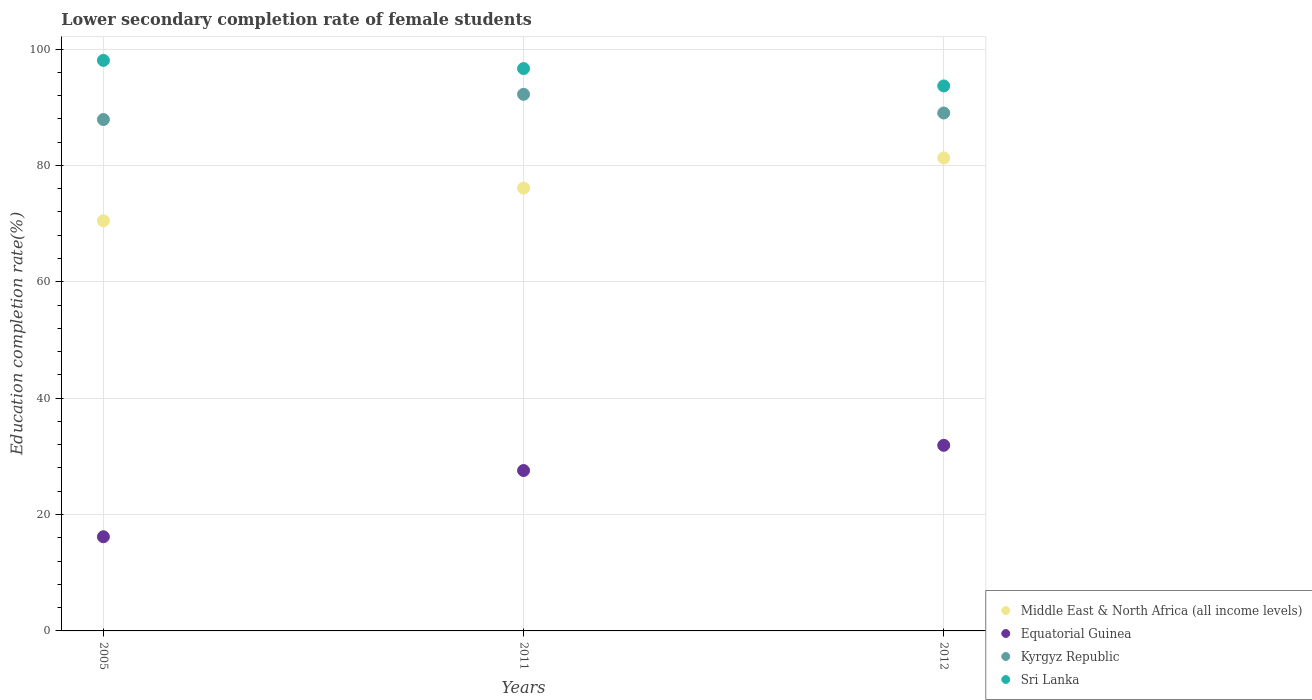Is the number of dotlines equal to the number of legend labels?
Keep it short and to the point. Yes. What is the lower secondary completion rate of female students in Sri Lanka in 2011?
Your answer should be very brief. 96.65. Across all years, what is the maximum lower secondary completion rate of female students in Kyrgyz Republic?
Your answer should be compact. 92.22. Across all years, what is the minimum lower secondary completion rate of female students in Middle East & North Africa (all income levels)?
Your answer should be very brief. 70.49. In which year was the lower secondary completion rate of female students in Kyrgyz Republic minimum?
Give a very brief answer. 2005. What is the total lower secondary completion rate of female students in Sri Lanka in the graph?
Provide a short and direct response. 288.36. What is the difference between the lower secondary completion rate of female students in Kyrgyz Republic in 2005 and that in 2012?
Provide a short and direct response. -1.12. What is the difference between the lower secondary completion rate of female students in Sri Lanka in 2011 and the lower secondary completion rate of female students in Middle East & North Africa (all income levels) in 2012?
Offer a terse response. 15.36. What is the average lower secondary completion rate of female students in Equatorial Guinea per year?
Your answer should be compact. 25.22. In the year 2005, what is the difference between the lower secondary completion rate of female students in Middle East & North Africa (all income levels) and lower secondary completion rate of female students in Sri Lanka?
Ensure brevity in your answer.  -27.57. In how many years, is the lower secondary completion rate of female students in Kyrgyz Republic greater than 84 %?
Offer a very short reply. 3. What is the ratio of the lower secondary completion rate of female students in Sri Lanka in 2011 to that in 2012?
Ensure brevity in your answer.  1.03. What is the difference between the highest and the second highest lower secondary completion rate of female students in Equatorial Guinea?
Your answer should be very brief. 4.33. What is the difference between the highest and the lowest lower secondary completion rate of female students in Kyrgyz Republic?
Ensure brevity in your answer.  4.33. Is it the case that in every year, the sum of the lower secondary completion rate of female students in Sri Lanka and lower secondary completion rate of female students in Kyrgyz Republic  is greater than the lower secondary completion rate of female students in Middle East & North Africa (all income levels)?
Offer a very short reply. Yes. Does the lower secondary completion rate of female students in Sri Lanka monotonically increase over the years?
Make the answer very short. No. Is the lower secondary completion rate of female students in Equatorial Guinea strictly greater than the lower secondary completion rate of female students in Middle East & North Africa (all income levels) over the years?
Provide a short and direct response. No. Is the lower secondary completion rate of female students in Sri Lanka strictly less than the lower secondary completion rate of female students in Equatorial Guinea over the years?
Provide a short and direct response. No. Are the values on the major ticks of Y-axis written in scientific E-notation?
Keep it short and to the point. No. Does the graph contain any zero values?
Ensure brevity in your answer.  No. Does the graph contain grids?
Keep it short and to the point. Yes. Where does the legend appear in the graph?
Provide a succinct answer. Bottom right. How many legend labels are there?
Your answer should be very brief. 4. What is the title of the graph?
Provide a short and direct response. Lower secondary completion rate of female students. What is the label or title of the Y-axis?
Provide a succinct answer. Education completion rate(%). What is the Education completion rate(%) in Middle East & North Africa (all income levels) in 2005?
Give a very brief answer. 70.49. What is the Education completion rate(%) in Equatorial Guinea in 2005?
Your response must be concise. 16.18. What is the Education completion rate(%) of Kyrgyz Republic in 2005?
Give a very brief answer. 87.89. What is the Education completion rate(%) of Sri Lanka in 2005?
Make the answer very short. 98.05. What is the Education completion rate(%) in Middle East & North Africa (all income levels) in 2011?
Offer a terse response. 76.1. What is the Education completion rate(%) of Equatorial Guinea in 2011?
Ensure brevity in your answer.  27.57. What is the Education completion rate(%) in Kyrgyz Republic in 2011?
Your response must be concise. 92.22. What is the Education completion rate(%) in Sri Lanka in 2011?
Provide a short and direct response. 96.65. What is the Education completion rate(%) in Middle East & North Africa (all income levels) in 2012?
Make the answer very short. 81.29. What is the Education completion rate(%) of Equatorial Guinea in 2012?
Make the answer very short. 31.9. What is the Education completion rate(%) in Kyrgyz Republic in 2012?
Offer a very short reply. 89.01. What is the Education completion rate(%) of Sri Lanka in 2012?
Your answer should be compact. 93.66. Across all years, what is the maximum Education completion rate(%) of Middle East & North Africa (all income levels)?
Give a very brief answer. 81.29. Across all years, what is the maximum Education completion rate(%) in Equatorial Guinea?
Your answer should be compact. 31.9. Across all years, what is the maximum Education completion rate(%) in Kyrgyz Republic?
Your response must be concise. 92.22. Across all years, what is the maximum Education completion rate(%) of Sri Lanka?
Your answer should be compact. 98.05. Across all years, what is the minimum Education completion rate(%) in Middle East & North Africa (all income levels)?
Your answer should be compact. 70.49. Across all years, what is the minimum Education completion rate(%) in Equatorial Guinea?
Make the answer very short. 16.18. Across all years, what is the minimum Education completion rate(%) of Kyrgyz Republic?
Keep it short and to the point. 87.89. Across all years, what is the minimum Education completion rate(%) in Sri Lanka?
Offer a very short reply. 93.66. What is the total Education completion rate(%) in Middle East & North Africa (all income levels) in the graph?
Provide a short and direct response. 227.87. What is the total Education completion rate(%) of Equatorial Guinea in the graph?
Your response must be concise. 75.65. What is the total Education completion rate(%) of Kyrgyz Republic in the graph?
Provide a short and direct response. 269.12. What is the total Education completion rate(%) of Sri Lanka in the graph?
Offer a terse response. 288.36. What is the difference between the Education completion rate(%) in Middle East & North Africa (all income levels) in 2005 and that in 2011?
Provide a succinct answer. -5.61. What is the difference between the Education completion rate(%) in Equatorial Guinea in 2005 and that in 2011?
Your answer should be very brief. -11.38. What is the difference between the Education completion rate(%) in Kyrgyz Republic in 2005 and that in 2011?
Provide a short and direct response. -4.33. What is the difference between the Education completion rate(%) in Sri Lanka in 2005 and that in 2011?
Offer a very short reply. 1.41. What is the difference between the Education completion rate(%) of Middle East & North Africa (all income levels) in 2005 and that in 2012?
Offer a very short reply. -10.8. What is the difference between the Education completion rate(%) in Equatorial Guinea in 2005 and that in 2012?
Your answer should be compact. -15.71. What is the difference between the Education completion rate(%) of Kyrgyz Republic in 2005 and that in 2012?
Provide a succinct answer. -1.12. What is the difference between the Education completion rate(%) of Sri Lanka in 2005 and that in 2012?
Your response must be concise. 4.39. What is the difference between the Education completion rate(%) in Middle East & North Africa (all income levels) in 2011 and that in 2012?
Provide a short and direct response. -5.19. What is the difference between the Education completion rate(%) in Equatorial Guinea in 2011 and that in 2012?
Provide a short and direct response. -4.33. What is the difference between the Education completion rate(%) in Kyrgyz Republic in 2011 and that in 2012?
Make the answer very short. 3.21. What is the difference between the Education completion rate(%) in Sri Lanka in 2011 and that in 2012?
Your answer should be very brief. 2.98. What is the difference between the Education completion rate(%) in Middle East & North Africa (all income levels) in 2005 and the Education completion rate(%) in Equatorial Guinea in 2011?
Give a very brief answer. 42.92. What is the difference between the Education completion rate(%) in Middle East & North Africa (all income levels) in 2005 and the Education completion rate(%) in Kyrgyz Republic in 2011?
Give a very brief answer. -21.74. What is the difference between the Education completion rate(%) in Middle East & North Africa (all income levels) in 2005 and the Education completion rate(%) in Sri Lanka in 2011?
Provide a succinct answer. -26.16. What is the difference between the Education completion rate(%) of Equatorial Guinea in 2005 and the Education completion rate(%) of Kyrgyz Republic in 2011?
Ensure brevity in your answer.  -76.04. What is the difference between the Education completion rate(%) in Equatorial Guinea in 2005 and the Education completion rate(%) in Sri Lanka in 2011?
Your answer should be compact. -80.46. What is the difference between the Education completion rate(%) in Kyrgyz Republic in 2005 and the Education completion rate(%) in Sri Lanka in 2011?
Ensure brevity in your answer.  -8.76. What is the difference between the Education completion rate(%) in Middle East & North Africa (all income levels) in 2005 and the Education completion rate(%) in Equatorial Guinea in 2012?
Offer a very short reply. 38.59. What is the difference between the Education completion rate(%) of Middle East & North Africa (all income levels) in 2005 and the Education completion rate(%) of Kyrgyz Republic in 2012?
Keep it short and to the point. -18.52. What is the difference between the Education completion rate(%) of Middle East & North Africa (all income levels) in 2005 and the Education completion rate(%) of Sri Lanka in 2012?
Offer a very short reply. -23.18. What is the difference between the Education completion rate(%) of Equatorial Guinea in 2005 and the Education completion rate(%) of Kyrgyz Republic in 2012?
Give a very brief answer. -72.83. What is the difference between the Education completion rate(%) in Equatorial Guinea in 2005 and the Education completion rate(%) in Sri Lanka in 2012?
Your answer should be very brief. -77.48. What is the difference between the Education completion rate(%) of Kyrgyz Republic in 2005 and the Education completion rate(%) of Sri Lanka in 2012?
Provide a succinct answer. -5.77. What is the difference between the Education completion rate(%) in Middle East & North Africa (all income levels) in 2011 and the Education completion rate(%) in Equatorial Guinea in 2012?
Your answer should be compact. 44.2. What is the difference between the Education completion rate(%) in Middle East & North Africa (all income levels) in 2011 and the Education completion rate(%) in Kyrgyz Republic in 2012?
Offer a very short reply. -12.91. What is the difference between the Education completion rate(%) of Middle East & North Africa (all income levels) in 2011 and the Education completion rate(%) of Sri Lanka in 2012?
Your answer should be very brief. -17.56. What is the difference between the Education completion rate(%) of Equatorial Guinea in 2011 and the Education completion rate(%) of Kyrgyz Republic in 2012?
Keep it short and to the point. -61.44. What is the difference between the Education completion rate(%) of Equatorial Guinea in 2011 and the Education completion rate(%) of Sri Lanka in 2012?
Keep it short and to the point. -66.1. What is the difference between the Education completion rate(%) in Kyrgyz Republic in 2011 and the Education completion rate(%) in Sri Lanka in 2012?
Keep it short and to the point. -1.44. What is the average Education completion rate(%) in Middle East & North Africa (all income levels) per year?
Give a very brief answer. 75.96. What is the average Education completion rate(%) in Equatorial Guinea per year?
Your response must be concise. 25.22. What is the average Education completion rate(%) of Kyrgyz Republic per year?
Provide a short and direct response. 89.71. What is the average Education completion rate(%) in Sri Lanka per year?
Provide a succinct answer. 96.12. In the year 2005, what is the difference between the Education completion rate(%) of Middle East & North Africa (all income levels) and Education completion rate(%) of Equatorial Guinea?
Your answer should be compact. 54.3. In the year 2005, what is the difference between the Education completion rate(%) of Middle East & North Africa (all income levels) and Education completion rate(%) of Kyrgyz Republic?
Your response must be concise. -17.4. In the year 2005, what is the difference between the Education completion rate(%) in Middle East & North Africa (all income levels) and Education completion rate(%) in Sri Lanka?
Ensure brevity in your answer.  -27.57. In the year 2005, what is the difference between the Education completion rate(%) in Equatorial Guinea and Education completion rate(%) in Kyrgyz Republic?
Your response must be concise. -71.7. In the year 2005, what is the difference between the Education completion rate(%) of Equatorial Guinea and Education completion rate(%) of Sri Lanka?
Offer a very short reply. -81.87. In the year 2005, what is the difference between the Education completion rate(%) of Kyrgyz Republic and Education completion rate(%) of Sri Lanka?
Ensure brevity in your answer.  -10.16. In the year 2011, what is the difference between the Education completion rate(%) of Middle East & North Africa (all income levels) and Education completion rate(%) of Equatorial Guinea?
Your response must be concise. 48.53. In the year 2011, what is the difference between the Education completion rate(%) in Middle East & North Africa (all income levels) and Education completion rate(%) in Kyrgyz Republic?
Provide a succinct answer. -16.12. In the year 2011, what is the difference between the Education completion rate(%) of Middle East & North Africa (all income levels) and Education completion rate(%) of Sri Lanka?
Keep it short and to the point. -20.55. In the year 2011, what is the difference between the Education completion rate(%) of Equatorial Guinea and Education completion rate(%) of Kyrgyz Republic?
Your answer should be very brief. -64.66. In the year 2011, what is the difference between the Education completion rate(%) of Equatorial Guinea and Education completion rate(%) of Sri Lanka?
Keep it short and to the point. -69.08. In the year 2011, what is the difference between the Education completion rate(%) in Kyrgyz Republic and Education completion rate(%) in Sri Lanka?
Provide a short and direct response. -4.42. In the year 2012, what is the difference between the Education completion rate(%) in Middle East & North Africa (all income levels) and Education completion rate(%) in Equatorial Guinea?
Provide a short and direct response. 49.39. In the year 2012, what is the difference between the Education completion rate(%) in Middle East & North Africa (all income levels) and Education completion rate(%) in Kyrgyz Republic?
Your answer should be compact. -7.72. In the year 2012, what is the difference between the Education completion rate(%) of Middle East & North Africa (all income levels) and Education completion rate(%) of Sri Lanka?
Make the answer very short. -12.38. In the year 2012, what is the difference between the Education completion rate(%) in Equatorial Guinea and Education completion rate(%) in Kyrgyz Republic?
Offer a terse response. -57.11. In the year 2012, what is the difference between the Education completion rate(%) of Equatorial Guinea and Education completion rate(%) of Sri Lanka?
Your response must be concise. -61.76. In the year 2012, what is the difference between the Education completion rate(%) of Kyrgyz Republic and Education completion rate(%) of Sri Lanka?
Provide a succinct answer. -4.65. What is the ratio of the Education completion rate(%) in Middle East & North Africa (all income levels) in 2005 to that in 2011?
Provide a short and direct response. 0.93. What is the ratio of the Education completion rate(%) of Equatorial Guinea in 2005 to that in 2011?
Your answer should be very brief. 0.59. What is the ratio of the Education completion rate(%) in Kyrgyz Republic in 2005 to that in 2011?
Keep it short and to the point. 0.95. What is the ratio of the Education completion rate(%) of Sri Lanka in 2005 to that in 2011?
Offer a very short reply. 1.01. What is the ratio of the Education completion rate(%) of Middle East & North Africa (all income levels) in 2005 to that in 2012?
Your response must be concise. 0.87. What is the ratio of the Education completion rate(%) in Equatorial Guinea in 2005 to that in 2012?
Offer a terse response. 0.51. What is the ratio of the Education completion rate(%) in Kyrgyz Republic in 2005 to that in 2012?
Provide a succinct answer. 0.99. What is the ratio of the Education completion rate(%) of Sri Lanka in 2005 to that in 2012?
Keep it short and to the point. 1.05. What is the ratio of the Education completion rate(%) of Middle East & North Africa (all income levels) in 2011 to that in 2012?
Ensure brevity in your answer.  0.94. What is the ratio of the Education completion rate(%) of Equatorial Guinea in 2011 to that in 2012?
Ensure brevity in your answer.  0.86. What is the ratio of the Education completion rate(%) in Kyrgyz Republic in 2011 to that in 2012?
Your answer should be compact. 1.04. What is the ratio of the Education completion rate(%) in Sri Lanka in 2011 to that in 2012?
Your answer should be very brief. 1.03. What is the difference between the highest and the second highest Education completion rate(%) in Middle East & North Africa (all income levels)?
Provide a succinct answer. 5.19. What is the difference between the highest and the second highest Education completion rate(%) of Equatorial Guinea?
Make the answer very short. 4.33. What is the difference between the highest and the second highest Education completion rate(%) of Kyrgyz Republic?
Provide a succinct answer. 3.21. What is the difference between the highest and the second highest Education completion rate(%) of Sri Lanka?
Make the answer very short. 1.41. What is the difference between the highest and the lowest Education completion rate(%) of Middle East & North Africa (all income levels)?
Ensure brevity in your answer.  10.8. What is the difference between the highest and the lowest Education completion rate(%) of Equatorial Guinea?
Keep it short and to the point. 15.71. What is the difference between the highest and the lowest Education completion rate(%) in Kyrgyz Republic?
Give a very brief answer. 4.33. What is the difference between the highest and the lowest Education completion rate(%) of Sri Lanka?
Your response must be concise. 4.39. 